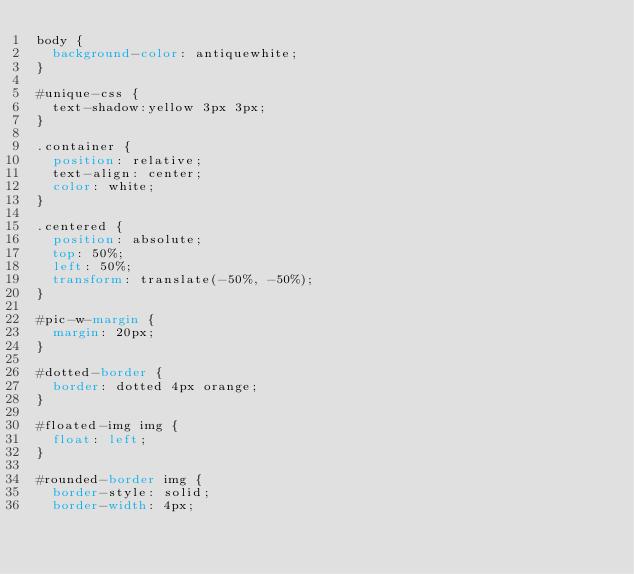Convert code to text. <code><loc_0><loc_0><loc_500><loc_500><_CSS_>body {
  background-color: antiquewhite;
}

#unique-css {
  text-shadow:yellow 3px 3px;
}

.container {
  position: relative;
  text-align: center;
  color: white;
}

.centered {
  position: absolute;
  top: 50%;
  left: 50%;
  transform: translate(-50%, -50%);
}

#pic-w-margin {
  margin: 20px;
}

#dotted-border {
  border: dotted 4px orange;
}

#floated-img img {
  float: left;
}

#rounded-border img {
  border-style: solid;
  border-width: 4px;</code> 